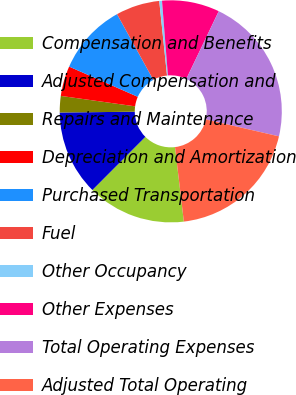<chart> <loc_0><loc_0><loc_500><loc_500><pie_chart><fcel>Compensation and Benefits<fcel>Adjusted Compensation and<fcel>Repairs and Maintenance<fcel>Depreciation and Amortization<fcel>Purchased Transportation<fcel>Fuel<fcel>Other Occupancy<fcel>Other Expenses<fcel>Total Operating Expenses<fcel>Adjusted Total Operating<nl><fcel>14.35%<fcel>12.36%<fcel>2.39%<fcel>4.38%<fcel>10.36%<fcel>6.38%<fcel>0.4%<fcel>8.37%<fcel>21.5%<fcel>19.5%<nl></chart> 